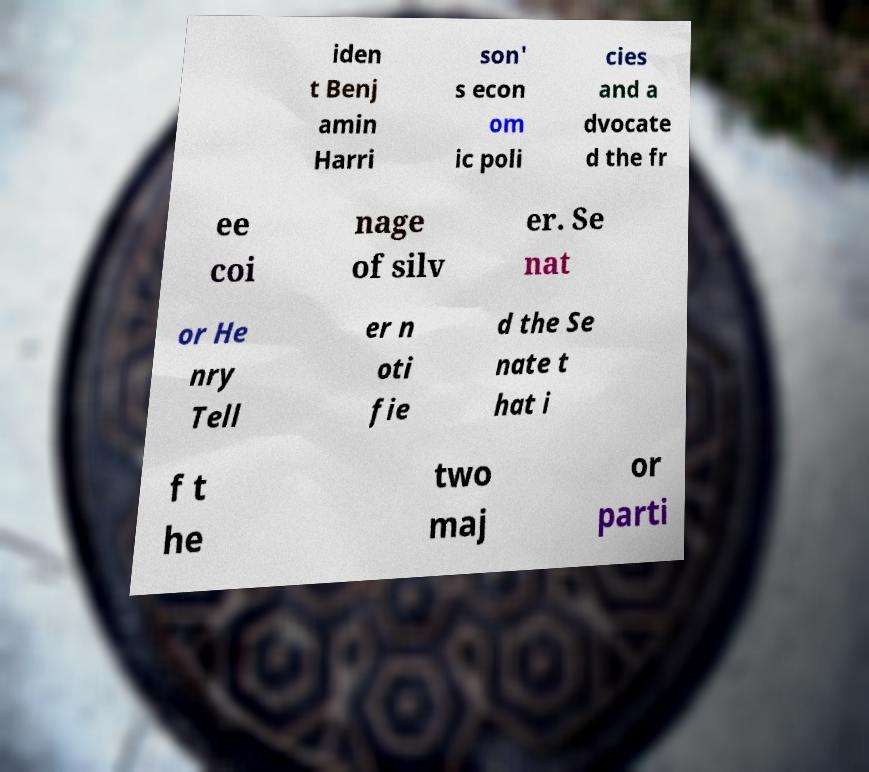Can you accurately transcribe the text from the provided image for me? iden t Benj amin Harri son' s econ om ic poli cies and a dvocate d the fr ee coi nage of silv er. Se nat or He nry Tell er n oti fie d the Se nate t hat i f t he two maj or parti 